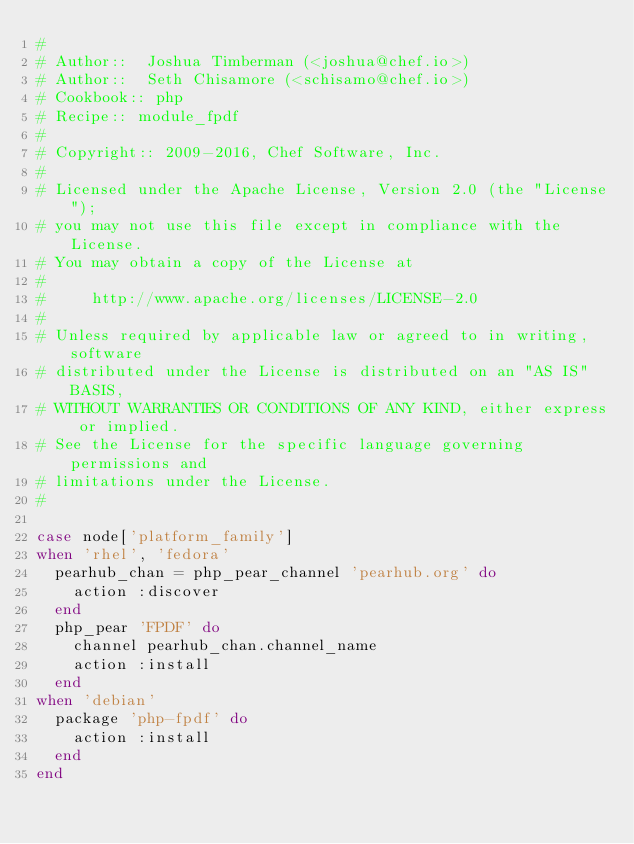Convert code to text. <code><loc_0><loc_0><loc_500><loc_500><_Ruby_>#
# Author::  Joshua Timberman (<joshua@chef.io>)
# Author::  Seth Chisamore (<schisamo@chef.io>)
# Cookbook:: php
# Recipe:: module_fpdf
#
# Copyright:: 2009-2016, Chef Software, Inc.
#
# Licensed under the Apache License, Version 2.0 (the "License");
# you may not use this file except in compliance with the License.
# You may obtain a copy of the License at
#
#     http://www.apache.org/licenses/LICENSE-2.0
#
# Unless required by applicable law or agreed to in writing, software
# distributed under the License is distributed on an "AS IS" BASIS,
# WITHOUT WARRANTIES OR CONDITIONS OF ANY KIND, either express or implied.
# See the License for the specific language governing permissions and
# limitations under the License.
#

case node['platform_family']
when 'rhel', 'fedora'
  pearhub_chan = php_pear_channel 'pearhub.org' do
    action :discover
  end
  php_pear 'FPDF' do
    channel pearhub_chan.channel_name
    action :install
  end
when 'debian'
  package 'php-fpdf' do
    action :install
  end
end
</code> 